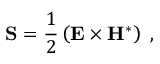Convert formula to latex. <formula><loc_0><loc_0><loc_500><loc_500>{ S } = \frac { 1 } { 2 } \left ( { E } \times { H } ^ { \ast } \right ) \, ,</formula> 